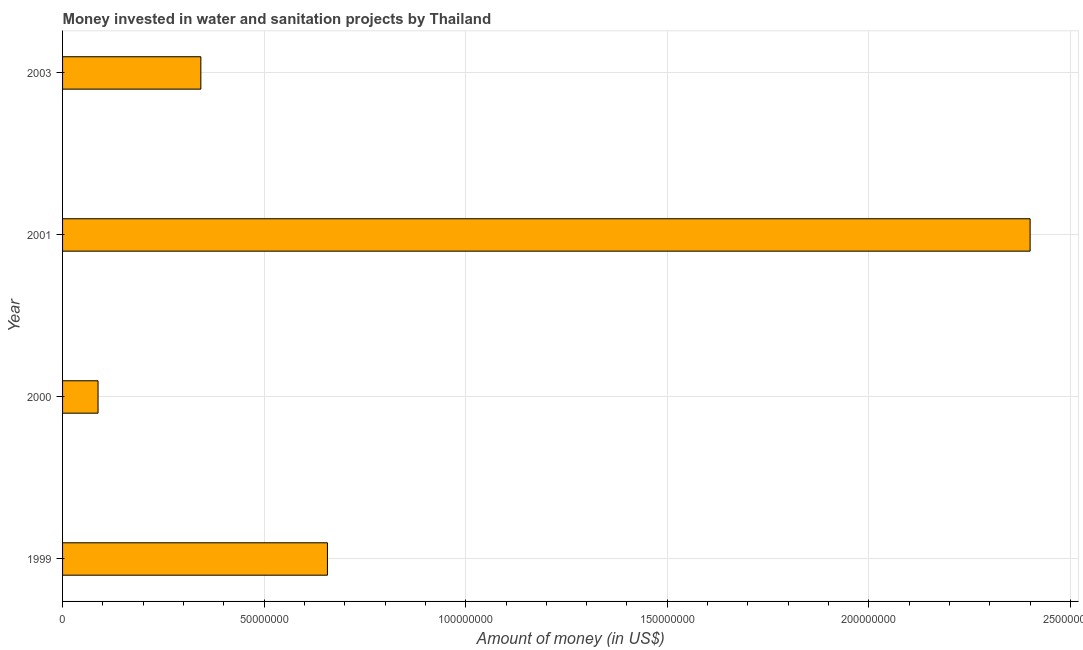Does the graph contain any zero values?
Ensure brevity in your answer.  No. Does the graph contain grids?
Offer a terse response. Yes. What is the title of the graph?
Make the answer very short. Money invested in water and sanitation projects by Thailand. What is the label or title of the X-axis?
Provide a short and direct response. Amount of money (in US$). What is the label or title of the Y-axis?
Keep it short and to the point. Year. What is the investment in 2003?
Your answer should be very brief. 3.43e+07. Across all years, what is the maximum investment?
Ensure brevity in your answer.  2.40e+08. Across all years, what is the minimum investment?
Make the answer very short. 8.80e+06. In which year was the investment maximum?
Your response must be concise. 2001. In which year was the investment minimum?
Your answer should be compact. 2000. What is the sum of the investment?
Give a very brief answer. 3.49e+08. What is the difference between the investment in 1999 and 2000?
Offer a very short reply. 5.69e+07. What is the average investment per year?
Make the answer very short. 8.72e+07. What is the median investment?
Ensure brevity in your answer.  5.00e+07. In how many years, is the investment greater than 190000000 US$?
Give a very brief answer. 1. Do a majority of the years between 1999 and 2000 (inclusive) have investment greater than 70000000 US$?
Ensure brevity in your answer.  No. What is the ratio of the investment in 1999 to that in 2000?
Your answer should be compact. 7.47. Is the difference between the investment in 2001 and 2003 greater than the difference between any two years?
Keep it short and to the point. No. What is the difference between the highest and the second highest investment?
Make the answer very short. 1.74e+08. Is the sum of the investment in 2001 and 2003 greater than the maximum investment across all years?
Ensure brevity in your answer.  Yes. What is the difference between the highest and the lowest investment?
Your response must be concise. 2.31e+08. In how many years, is the investment greater than the average investment taken over all years?
Your answer should be very brief. 1. How many bars are there?
Your answer should be compact. 4. Are all the bars in the graph horizontal?
Offer a terse response. Yes. How many years are there in the graph?
Provide a short and direct response. 4. What is the difference between two consecutive major ticks on the X-axis?
Offer a very short reply. 5.00e+07. Are the values on the major ticks of X-axis written in scientific E-notation?
Offer a terse response. No. What is the Amount of money (in US$) of 1999?
Offer a terse response. 6.57e+07. What is the Amount of money (in US$) of 2000?
Keep it short and to the point. 8.80e+06. What is the Amount of money (in US$) in 2001?
Keep it short and to the point. 2.40e+08. What is the Amount of money (in US$) of 2003?
Your answer should be very brief. 3.43e+07. What is the difference between the Amount of money (in US$) in 1999 and 2000?
Make the answer very short. 5.69e+07. What is the difference between the Amount of money (in US$) in 1999 and 2001?
Your answer should be compact. -1.74e+08. What is the difference between the Amount of money (in US$) in 1999 and 2003?
Provide a succinct answer. 3.14e+07. What is the difference between the Amount of money (in US$) in 2000 and 2001?
Make the answer very short. -2.31e+08. What is the difference between the Amount of money (in US$) in 2000 and 2003?
Give a very brief answer. -2.55e+07. What is the difference between the Amount of money (in US$) in 2001 and 2003?
Your answer should be compact. 2.06e+08. What is the ratio of the Amount of money (in US$) in 1999 to that in 2000?
Your response must be concise. 7.47. What is the ratio of the Amount of money (in US$) in 1999 to that in 2001?
Offer a very short reply. 0.27. What is the ratio of the Amount of money (in US$) in 1999 to that in 2003?
Offer a terse response. 1.92. What is the ratio of the Amount of money (in US$) in 2000 to that in 2001?
Ensure brevity in your answer.  0.04. What is the ratio of the Amount of money (in US$) in 2000 to that in 2003?
Provide a short and direct response. 0.26. What is the ratio of the Amount of money (in US$) in 2001 to that in 2003?
Your answer should be very brief. 7. 